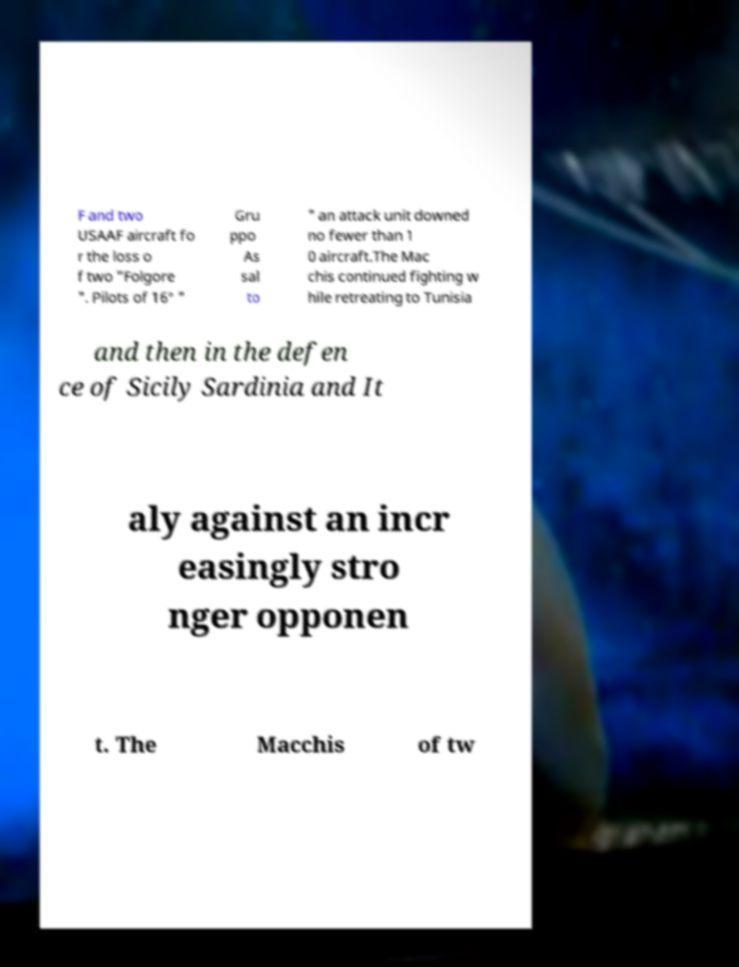There's text embedded in this image that I need extracted. Can you transcribe it verbatim? F and two USAAF aircraft fo r the loss o f two "Folgore ". Pilots of 16° " Gru ppo As sal to " an attack unit downed no fewer than 1 0 aircraft.The Mac chis continued fighting w hile retreating to Tunisia and then in the defen ce of Sicily Sardinia and It aly against an incr easingly stro nger opponen t. The Macchis of tw 